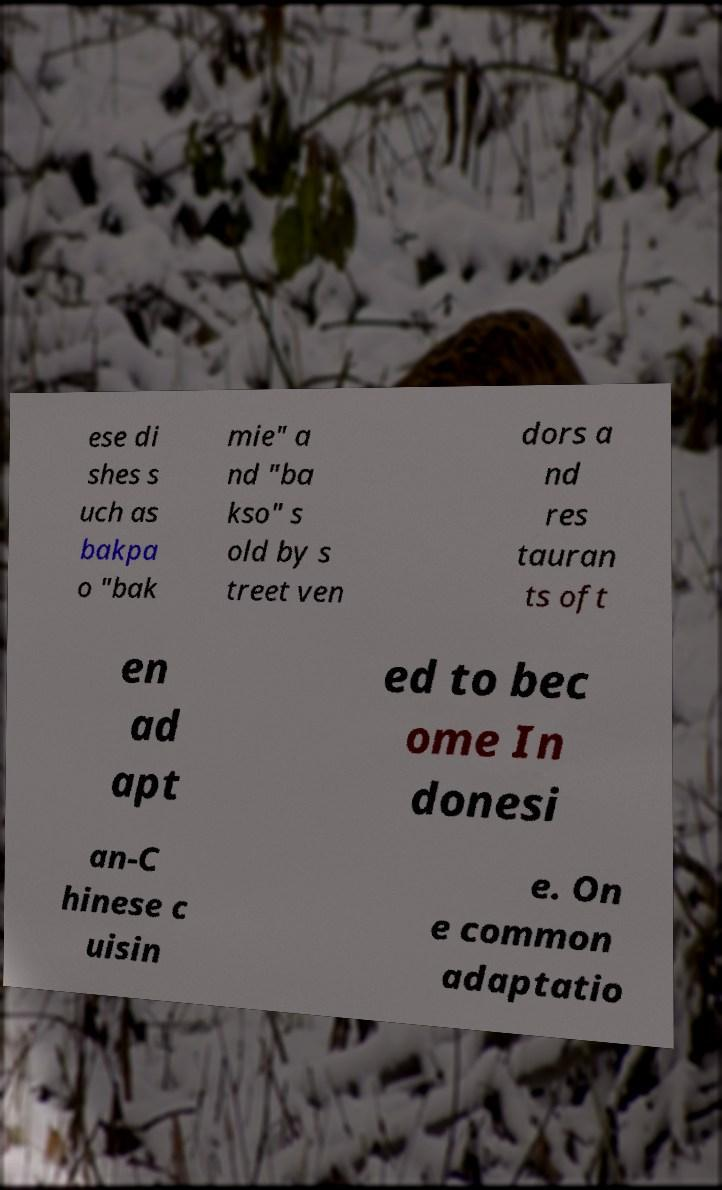Can you read and provide the text displayed in the image?This photo seems to have some interesting text. Can you extract and type it out for me? ese di shes s uch as bakpa o "bak mie" a nd "ba kso" s old by s treet ven dors a nd res tauran ts oft en ad apt ed to bec ome In donesi an-C hinese c uisin e. On e common adaptatio 